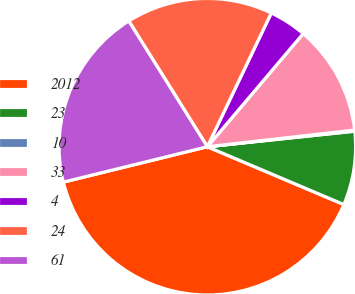Convert chart. <chart><loc_0><loc_0><loc_500><loc_500><pie_chart><fcel>2012<fcel>23<fcel>10<fcel>33<fcel>4<fcel>24<fcel>61<nl><fcel>39.79%<fcel>8.05%<fcel>0.12%<fcel>12.02%<fcel>4.09%<fcel>15.99%<fcel>19.95%<nl></chart> 